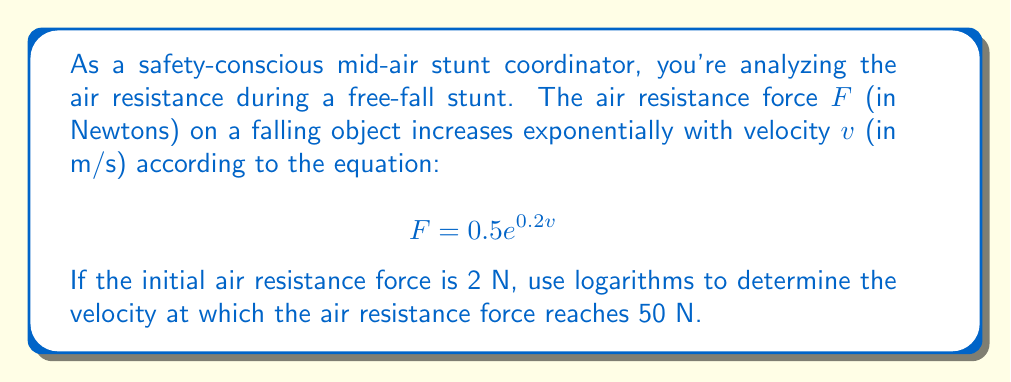Can you answer this question? Let's approach this step-by-step using logarithms:

1) We start with the equation: $F = 0.5e^{0.2v}$

2) We want to find $v$ when $F = 50$ N. So, let's substitute this:

   $50 = 0.5e^{0.2v}$

3) First, let's isolate the exponential term:

   $100 = e^{0.2v}$

4) Now, we can apply the natural logarithm to both sides:

   $\ln(100) = \ln(e^{0.2v})$

5) Using the logarithm property $\ln(e^x) = x$, we get:

   $\ln(100) = 0.2v$

6) Now we can solve for $v$:

   $v = \frac{\ln(100)}{0.2}$

7) $\ln(100) \approx 4.60517$

8) Therefore:

   $v = \frac{4.60517}{0.2} \approx 23.02585$ m/s

This velocity represents a significant increase from the initial condition. At the start, when $F = 2$ N:

$2 = 0.5e^{0.2v_0}$
$4 = e^{0.2v_0}$
$\ln(4) = 0.2v_0$
$v_0 = \frac{\ln(4)}{0.2} \approx 6.93147$ m/s

The velocity has more than tripled, demonstrating the rapid increase in air resistance with velocity.
Answer: The velocity at which the air resistance force reaches 50 N is approximately 23.03 m/s. 